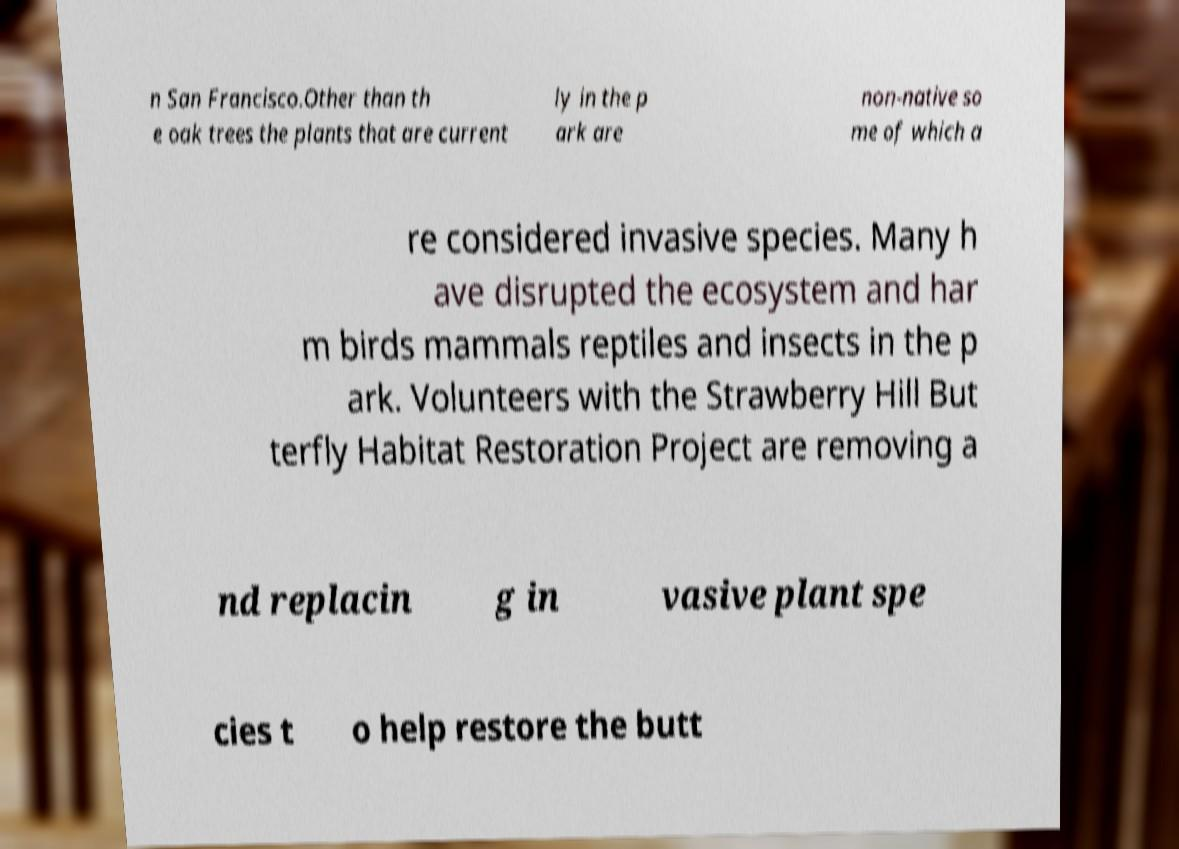I need the written content from this picture converted into text. Can you do that? n San Francisco.Other than th e oak trees the plants that are current ly in the p ark are non-native so me of which a re considered invasive species. Many h ave disrupted the ecosystem and har m birds mammals reptiles and insects in the p ark. Volunteers with the Strawberry Hill But terfly Habitat Restoration Project are removing a nd replacin g in vasive plant spe cies t o help restore the butt 